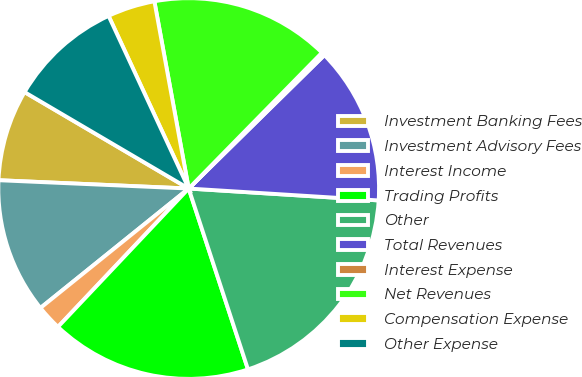Convert chart. <chart><loc_0><loc_0><loc_500><loc_500><pie_chart><fcel>Investment Banking Fees<fcel>Investment Advisory Fees<fcel>Interest Income<fcel>Trading Profits<fcel>Other<fcel>Total Revenues<fcel>Interest Expense<fcel>Net Revenues<fcel>Compensation Expense<fcel>Other Expense<nl><fcel>7.76%<fcel>11.49%<fcel>2.16%<fcel>17.09%<fcel>18.96%<fcel>13.36%<fcel>0.29%<fcel>15.23%<fcel>4.03%<fcel>9.63%<nl></chart> 